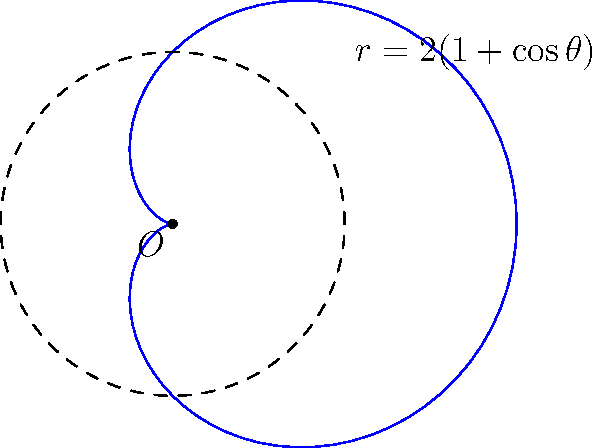As a retired journalist with experience in the British press, you've been asked to fact-check a mathematical claim in an article. The article states that the area enclosed by the cardioid curve $r = 2(1 + \cos\theta)$ is equal to $6\pi$ square units. Is this claim correct? If not, what is the correct area? Let's approach this step-by-step:

1) The formula for the area enclosed by a polar curve is:

   $$A = \frac{1}{2} \int_{0}^{2\pi} r^2 d\theta$$

2) In this case, $r = 2(1 + \cos\theta)$, so we need to calculate:

   $$A = \frac{1}{2} \int_{0}^{2\pi} [2(1 + \cos\theta)]^2 d\theta$$

3) Expanding the squared term:

   $$A = \frac{1}{2} \int_{0}^{2\pi} 4(1 + 2\cos\theta + \cos^2\theta) d\theta$$

4) Simplifying:

   $$A = 2 \int_{0}^{2\pi} (1 + 2\cos\theta + \cos^2\theta) d\theta$$

5) We can integrate each term separately:

   $$A = 2 [\theta + 2\sin\theta + \frac{1}{2}\theta + \frac{1}{4}\sin(2\theta)]_{0}^{2\pi}$$

6) Evaluating from 0 to $2\pi$:

   $$A = 2 [(2\pi + 0 + \pi + 0) - (0 + 0 + 0 + 0)]$$

7) Simplifying:

   $$A = 2(3\pi) = 6\pi$$

Therefore, the claim in the article is correct. The area enclosed by the cardioid curve $r = 2(1 + \cos\theta)$ is indeed $6\pi$ square units.
Answer: $6\pi$ square units 